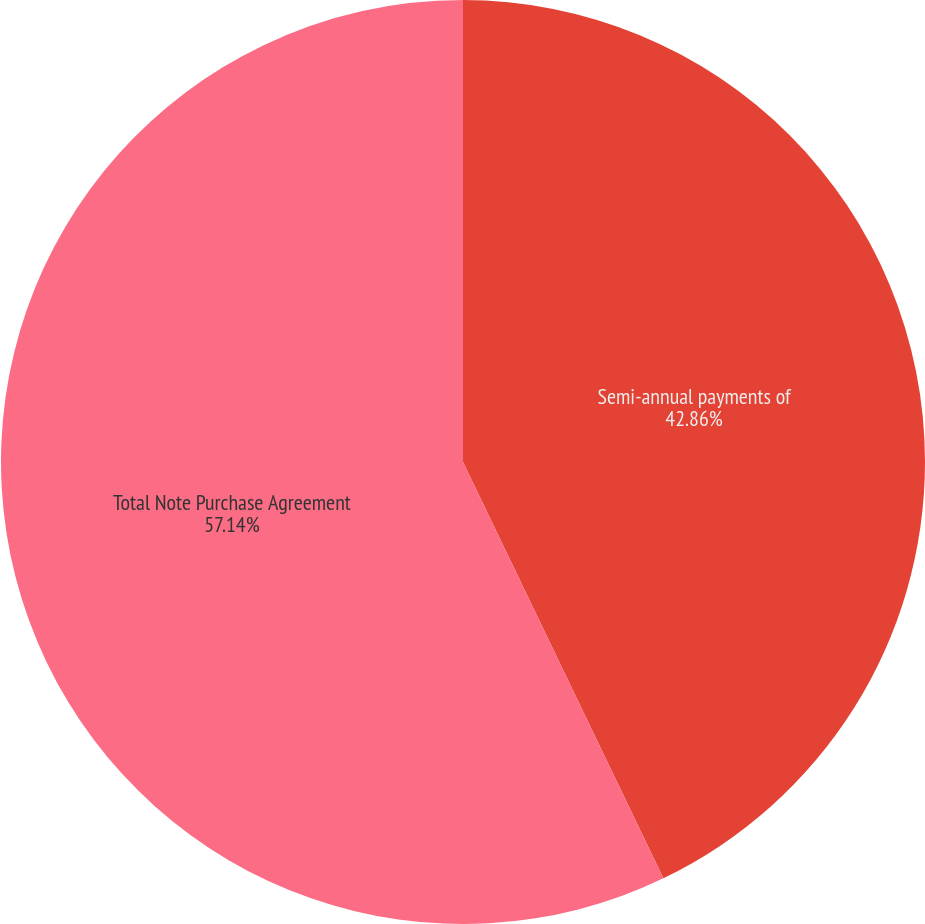<chart> <loc_0><loc_0><loc_500><loc_500><pie_chart><fcel>Semi-annual payments of<fcel>Total Note Purchase Agreement<nl><fcel>42.86%<fcel>57.14%<nl></chart> 